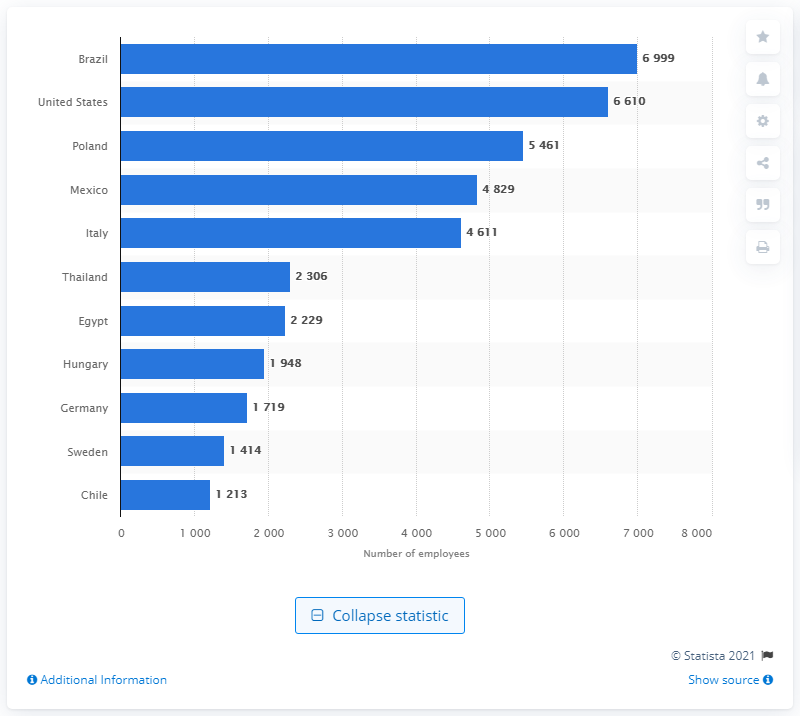Draw attention to some important aspects in this diagram. Electrolux employed almost seven thousand people in Brazil in 2020. 